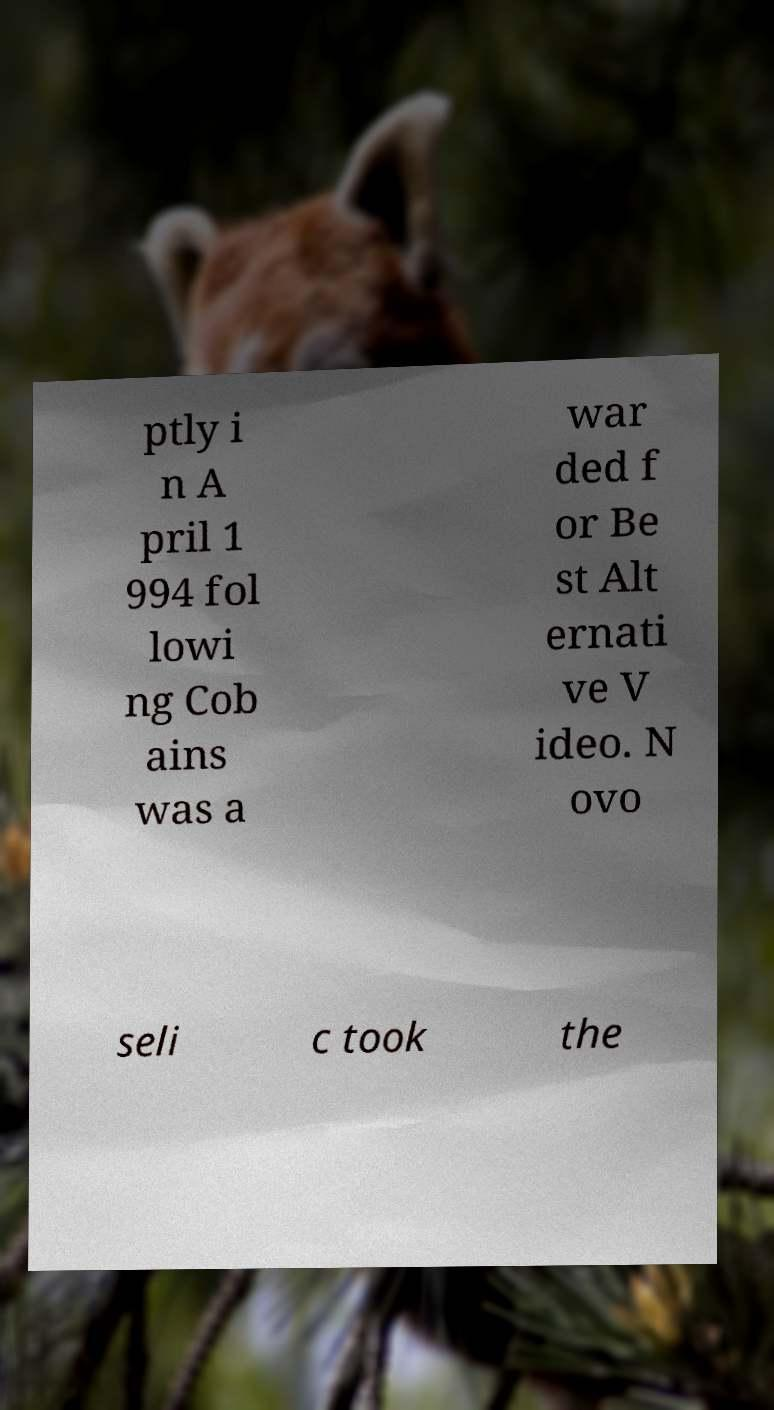Could you assist in decoding the text presented in this image and type it out clearly? ptly i n A pril 1 994 fol lowi ng Cob ains was a war ded f or Be st Alt ernati ve V ideo. N ovo seli c took the 